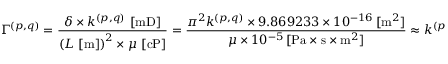Convert formula to latex. <formula><loc_0><loc_0><loc_500><loc_500>\Gamma ^ { ( p , q ) } = \frac { \delta \times k ^ { ( p , q ) } \, \left [ { m D } \right ] } { \left ( L \, \left [ { m } \right ] \right ) ^ { 2 } \times \mu \, \left [ { c P } \right ] } = \frac { \pi ^ { 2 } k ^ { ( p , q ) } \times 9 . 8 6 9 2 3 3 \times 1 0 ^ { - 1 6 } \, [ { m } ^ { 2 } ] } { \mu \times 1 0 ^ { - 5 } \, [ { P a } \times { s } \times { m } ^ { 2 } ] } \approx k ^ { ( p , q ) } \, \left [ \frac { 1 } { { G P a } \times { s } } \right ] \, ,</formula> 